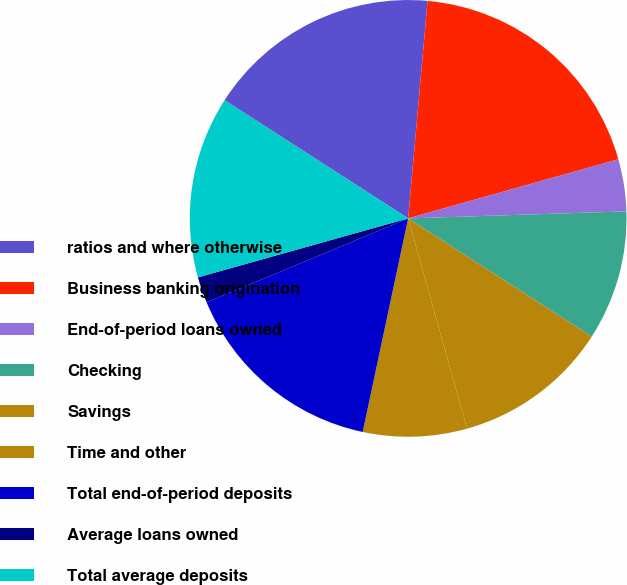<chart> <loc_0><loc_0><loc_500><loc_500><pie_chart><fcel>ratios and where otherwise<fcel>Business banking origination<fcel>End-of-period loans owned<fcel>Checking<fcel>Savings<fcel>Time and other<fcel>Total end-of-period deposits<fcel>Average loans owned<fcel>Total average deposits<fcel>Deposit margin<nl><fcel>17.3%<fcel>19.22%<fcel>3.85%<fcel>9.62%<fcel>11.54%<fcel>7.69%<fcel>15.38%<fcel>1.93%<fcel>13.46%<fcel>0.01%<nl></chart> 